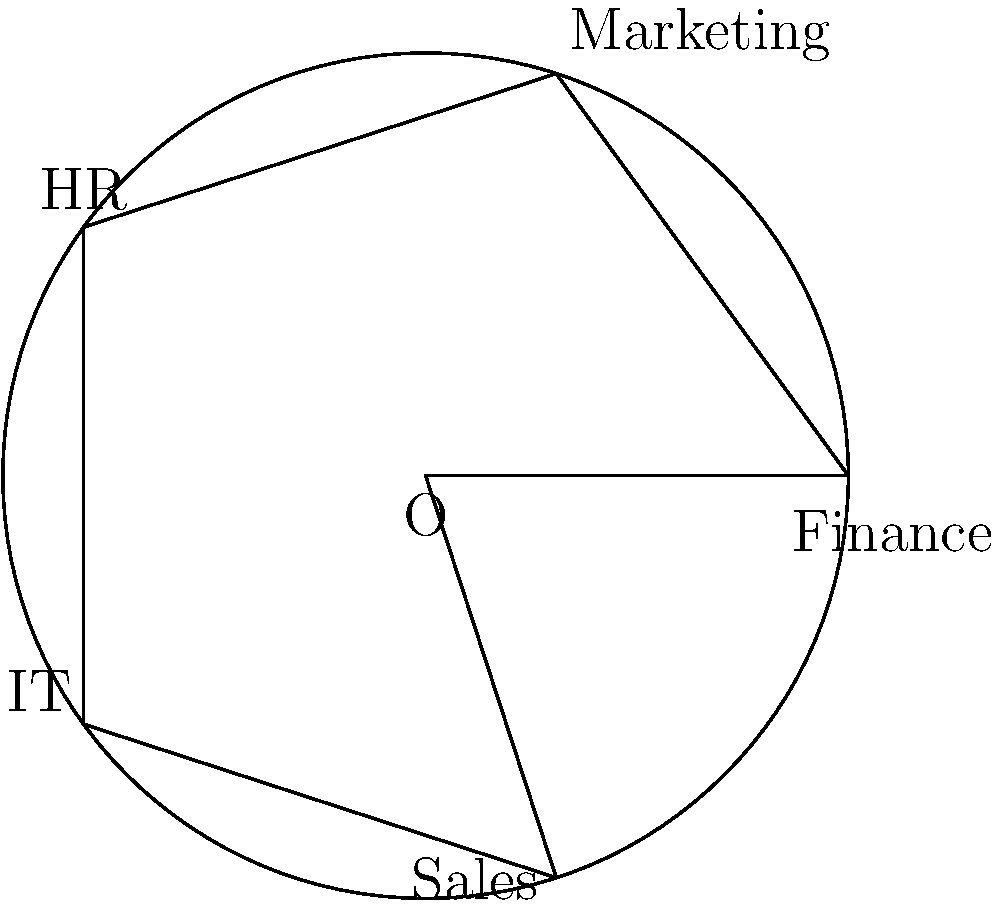A career path diagram is represented as a regular pentagon inscribed in a circle, with each vertex representing a different job opportunity (Finance, Marketing, HR, IT, and Sales). If this diagram is rotated $144°$ counterclockwise around its center, which job opportunity will be at the position originally occupied by "Finance"? To solve this problem, we need to follow these steps:

1. Understand the initial position:
   - The diagram is a regular pentagon inscribed in a circle.
   - Each vertex represents a job opportunity.
   - "Finance" is at the rightmost vertex (3 o'clock position).

2. Analyze the rotation:
   - The diagram is rotated $144°$ counterclockwise.
   - In a regular pentagon, each vertex is $72°$ apart ($360° ÷ 5 = 72°$).
   - A $144°$ rotation is equivalent to moving 2 vertices counterclockwise ($144° ÷ 72° = 2$).

3. Trace the movement:
   - Starting from "Finance", we move 2 vertices counterclockwise.
   - The order of job opportunities clockwise is: Finance → Sales → IT → HR → Marketing.
   - Moving 2 positions counterclockwise from Finance, we land on HR.

Therefore, after a $144°$ counterclockwise rotation, the HR job opportunity will be at the position originally occupied by Finance.
Answer: HR 